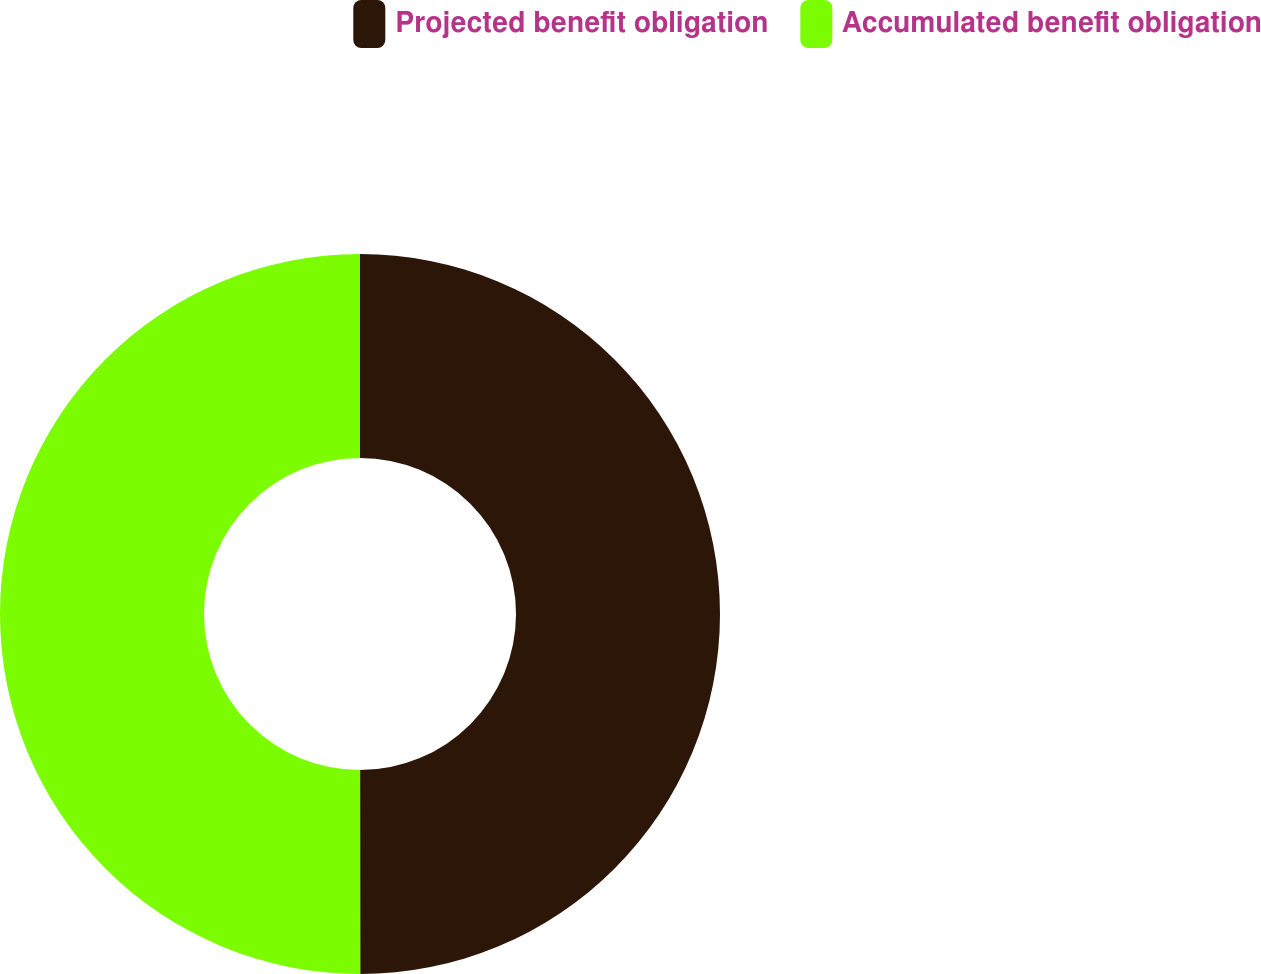Convert chart to OTSL. <chart><loc_0><loc_0><loc_500><loc_500><pie_chart><fcel>Projected benefit obligation<fcel>Accumulated benefit obligation<nl><fcel>49.99%<fcel>50.01%<nl></chart> 